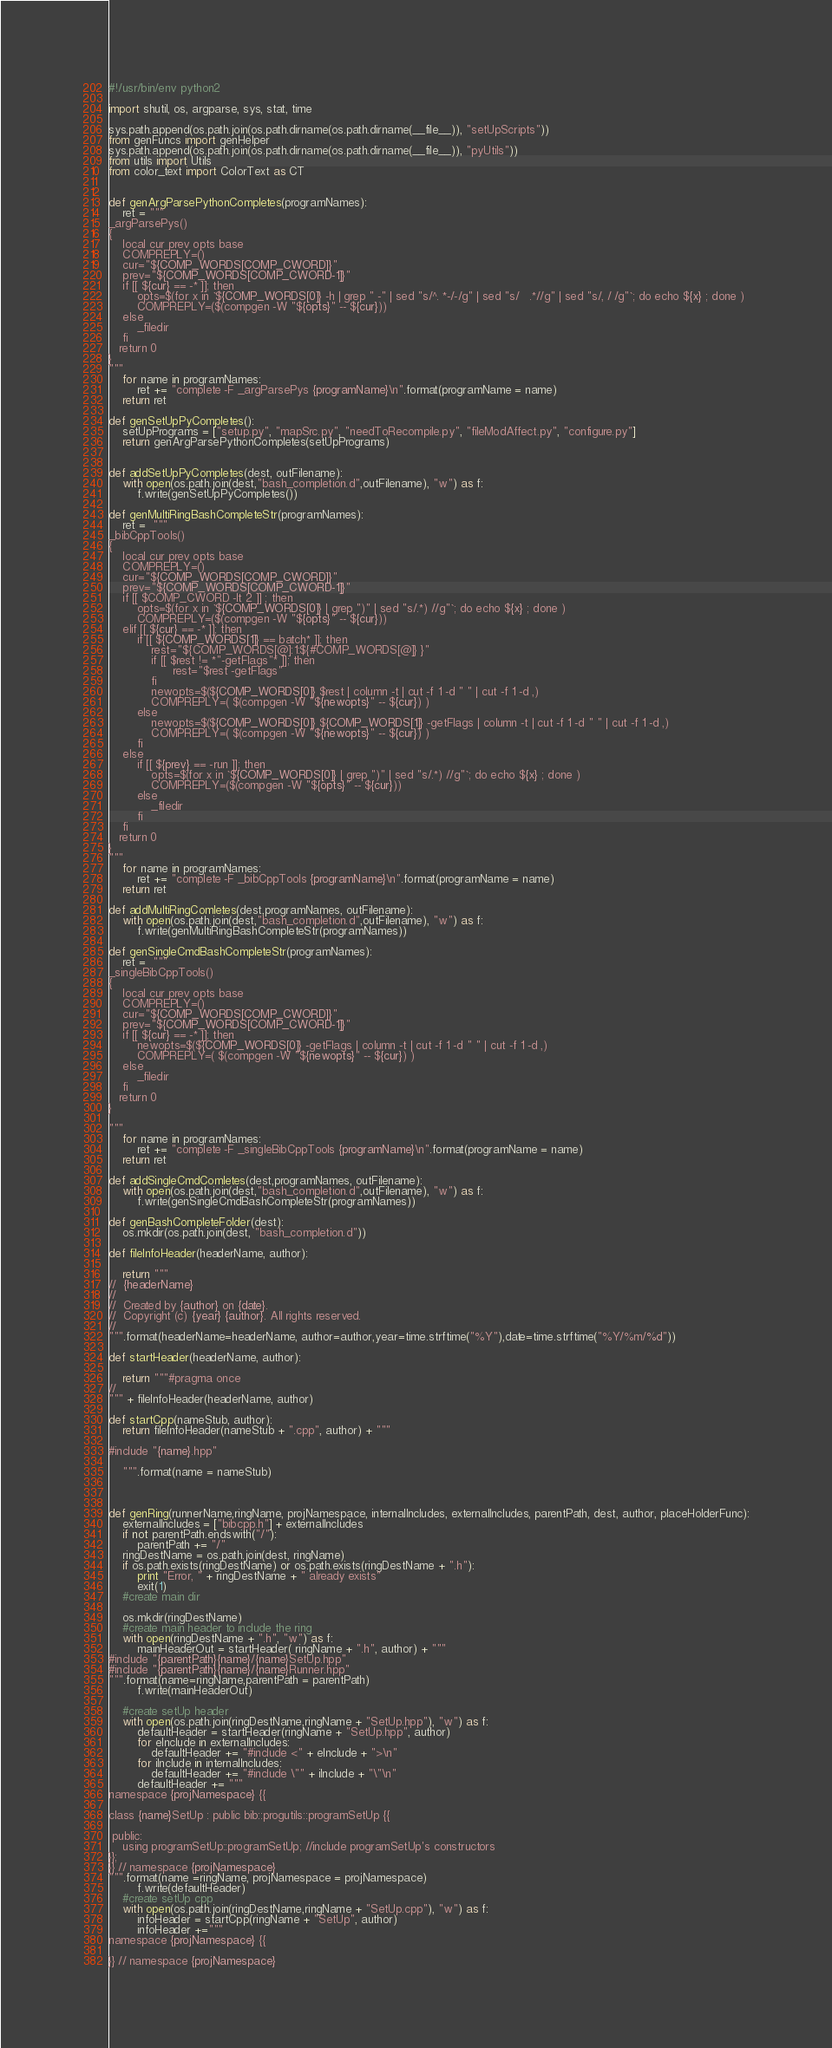<code> <loc_0><loc_0><loc_500><loc_500><_Python_>#!/usr/bin/env python2

import shutil, os, argparse, sys, stat, time

sys.path.append(os.path.join(os.path.dirname(os.path.dirname(__file__)), "setUpScripts"))
from genFuncs import genHelper
sys.path.append(os.path.join(os.path.dirname(os.path.dirname(__file__)), "pyUtils"))
from utils import Utils
from color_text import ColorText as CT


def genArgParsePythonCompletes(programNames):
    ret = """
_argParsePys()
{
    local cur prev opts base
    COMPREPLY=()
    cur="${COMP_WORDS[COMP_CWORD]}"
    prev="${COMP_WORDS[COMP_CWORD-1]}"
    if [[ ${cur} == -* ]]; then
        opts=$(for x in `${COMP_WORDS[0]} -h | grep " -" | sed "s/^. *-/-/g" | sed "s/   .*//g" | sed "s/, / /g"`; do echo ${x} ; done )
        COMPREPLY=($(compgen -W "${opts}" -- ${cur}))
    else
        _filedir
    fi
   return 0
}
"""
    for name in programNames:
        ret += "complete -F _argParsePys {programName}\n".format(programName = name)
    return ret

def genSetUpPyCompletes():
    setUpPrograms = ["setup.py", "mapSrc.py", "needToRecompile.py", "fileModAffect.py", "configure.py"]
    return genArgParsePythonCompletes(setUpPrograms)


def addSetUpPyCompletes(dest, outFilename):
    with open(os.path.join(dest,"bash_completion.d",outFilename), "w") as f:
        f.write(genSetUpPyCompletes())

def genMultiRingBashCompleteStr(programNames):
    ret =  """
_bibCppTools()
{
    local cur prev opts base
    COMPREPLY=()
    cur="${COMP_WORDS[COMP_CWORD]}"
    prev="${COMP_WORDS[COMP_CWORD-1]}"
    if [[ $COMP_CWORD -lt 2 ]] ; then
        opts=$(for x in `${COMP_WORDS[0]} | grep ")" | sed "s/.*) //g"`; do echo ${x} ; done )
        COMPREPLY=($(compgen -W "${opts}" -- ${cur}))
    elif [[ ${cur} == -* ]]; then
        if [[ ${COMP_WORDS[1]} == batch* ]]; then
            rest="${COMP_WORDS[@]:1:${#COMP_WORDS[@]} }"
            if [[ $rest != *"-getFlags"* ]]; then
                  rest="$rest -getFlags"
            fi
            newopts=$(${COMP_WORDS[0]} $rest | column -t | cut -f 1 -d " " | cut -f 1 -d ,)
            COMPREPLY=( $(compgen -W "${newopts}" -- ${cur}) )
        else
            newopts=$(${COMP_WORDS[0]} ${COMP_WORDS[1]} -getFlags | column -t | cut -f 1 -d " " | cut -f 1 -d ,)
            COMPREPLY=( $(compgen -W "${newopts}" -- ${cur}) )
        fi
    else
        if [[ ${prev} == -run ]]; then
            opts=$(for x in `${COMP_WORDS[0]} | grep ")" | sed "s/.*) //g"`; do echo ${x} ; done )
            COMPREPLY=($(compgen -W "${opts}" -- ${cur}))
        else
            _filedir
        fi
    fi
   return 0
}
"""
    for name in programNames:
        ret += "complete -F _bibCppTools {programName}\n".format(programName = name)
    return ret

def addMultiRingComletes(dest,programNames, outFilename):
    with open(os.path.join(dest,"bash_completion.d",outFilename), "w") as f:
        f.write(genMultiRingBashCompleteStr(programNames))
        
def genSingleCmdBashCompleteStr(programNames):
    ret =  """
_singleBibCppTools()
{
    local cur prev opts base
    COMPREPLY=()
    cur="${COMP_WORDS[COMP_CWORD]}"
    prev="${COMP_WORDS[COMP_CWORD-1]}"
    if [[ ${cur} == -* ]]; then
        newopts=$(${COMP_WORDS[0]} -getFlags | column -t | cut -f 1 -d " " | cut -f 1 -d ,)
        COMPREPLY=( $(compgen -W "${newopts}" -- ${cur}) )
    else
        _filedir
    fi
   return 0
}

"""
    for name in programNames:
        ret += "complete -F _singleBibCppTools {programName}\n".format(programName = name)
    return ret

def addSingleCmdComletes(dest,programNames, outFilename):
    with open(os.path.join(dest,"bash_completion.d",outFilename), "w") as f:
        f.write(genSingleCmdBashCompleteStr(programNames))

def genBashCompleteFolder(dest):
    os.mkdir(os.path.join(dest, "bash_completion.d"))

def fileInfoHeader(headerName, author):
    
    return """
//  {headerName}
//
//  Created by {author} on {date}.
//  Copyright (c) {year} {author}. All rights reserved.
//
""".format(headerName=headerName, author=author,year=time.strftime("%Y"),date=time.strftime("%Y/%m/%d"))

def startHeader(headerName, author):
    
    return """#pragma once
//
""" + fileInfoHeader(headerName, author)

def startCpp(nameStub, author):
    return fileInfoHeader(nameStub + ".cpp", author) + """
    
#include "{name}.hpp"
    
    """.format(name = nameStub)



def genRing(runnerName,ringName, projNamespace, internalIncludes, externalIncludes, parentPath, dest, author, placeHolderFunc):
    externalIncludes = ["bibcpp.h"] + externalIncludes
    if not parentPath.endswith("/"):
        parentPath += "/"
    ringDestName = os.path.join(dest, ringName)
    if os.path.exists(ringDestName) or os.path.exists(ringDestName + ".h"):
        print "Error, " + ringDestName + " already exists"
        exit(1)
    #create main dir

    os.mkdir(ringDestName)
    #create main header to include the ring
    with open(ringDestName + ".h", "w") as f:
        mainHeaderOut = startHeader( ringName + ".h", author) + """
#include "{parentPath}{name}/{name}SetUp.hpp"
#include "{parentPath}{name}/{name}Runner.hpp"
""".format(name=ringName,parentPath = parentPath)
        f.write(mainHeaderOut)

    #create setUp header
    with open(os.path.join(ringDestName,ringName + "SetUp.hpp"), "w") as f:
        defaultHeader = startHeader(ringName + "SetUp.hpp", author)
        for eInclude in externalIncludes:
            defaultHeader += "#include <" + eInclude + ">\n"
        for iInclude in internalIncludes:
            defaultHeader += "#include \"" + iInclude + "\"\n"
        defaultHeader += """
namespace {projNamespace} {{

class {name}SetUp : public bib::progutils::programSetUp {{

 public:
    using programSetUp::programSetUp; //include programSetUp's constructors
}};
}} // namespace {projNamespace}
""".format(name =ringName, projNamespace = projNamespace)
        f.write(defaultHeader)
    #create setUp cpp
    with open(os.path.join(ringDestName,ringName + "SetUp.cpp"), "w") as f:
        infoHeader = startCpp(ringName + "SetUp", author)
        infoHeader +="""
namespace {projNamespace} {{

}} // namespace {projNamespace}</code> 